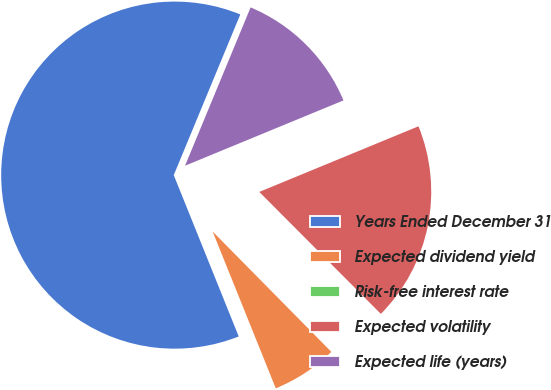Convert chart to OTSL. <chart><loc_0><loc_0><loc_500><loc_500><pie_chart><fcel>Years Ended December 31<fcel>Expected dividend yield<fcel>Risk-free interest rate<fcel>Expected volatility<fcel>Expected life (years)<nl><fcel>62.34%<fcel>6.3%<fcel>0.08%<fcel>18.75%<fcel>12.53%<nl></chart> 